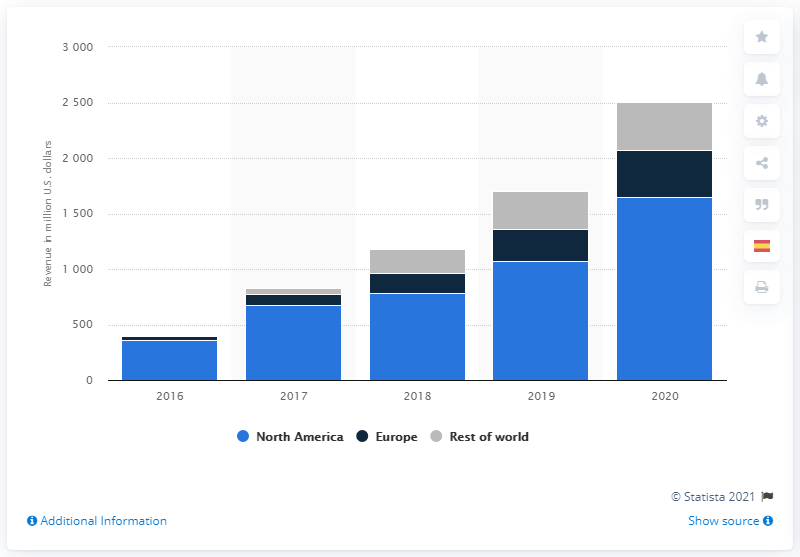Mention a couple of crucial points in this snapshot. In 2020, a total of 1,649.94 dollars were generated in North American markets. 